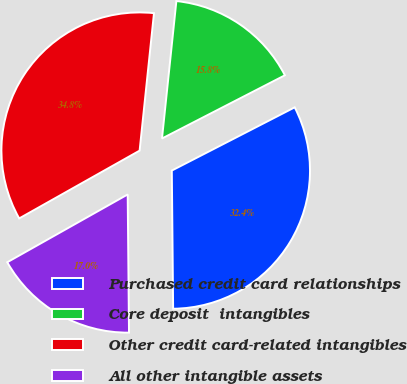<chart> <loc_0><loc_0><loc_500><loc_500><pie_chart><fcel>Purchased credit card relationships<fcel>Core deposit  intangibles<fcel>Other credit card-related intangibles<fcel>All other intangible assets<nl><fcel>32.41%<fcel>15.78%<fcel>34.82%<fcel>16.99%<nl></chart> 